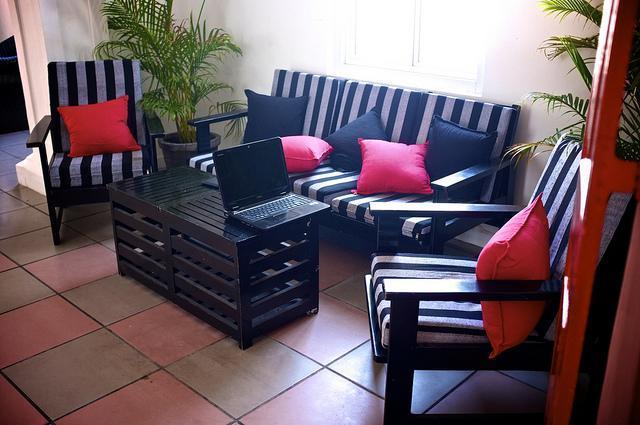How many tables are in the room?
Give a very brief answer. 1. How many potted plants are there?
Give a very brief answer. 2. How many umbrellas are visible?
Give a very brief answer. 0. 